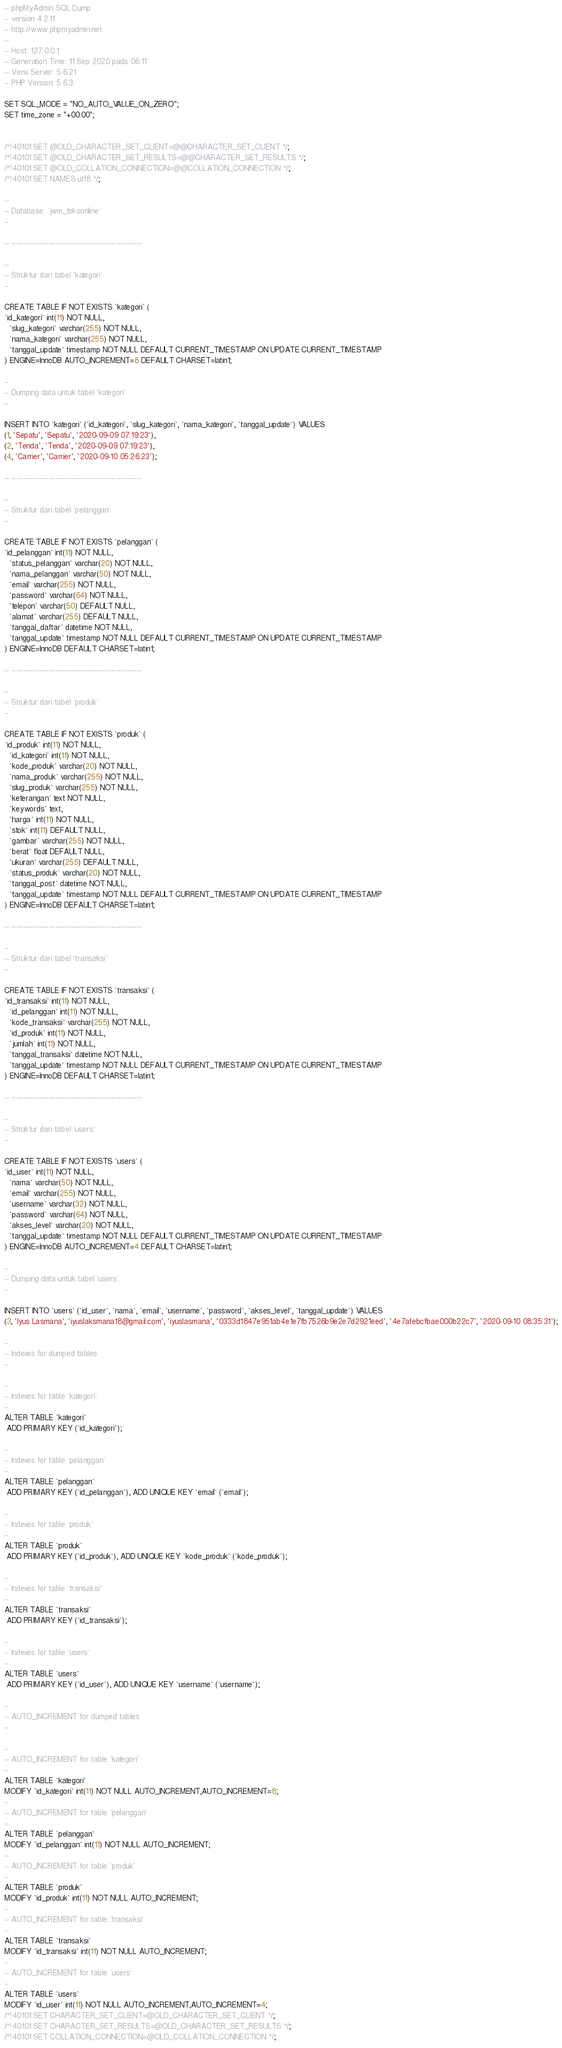<code> <loc_0><loc_0><loc_500><loc_500><_SQL_>-- phpMyAdmin SQL Dump
-- version 4.2.11
-- http://www.phpmyadmin.net
--
-- Host: 127.0.0.1
-- Generation Time: 11 Sep 2020 pada 06.11
-- Versi Server: 5.6.21
-- PHP Version: 5.6.3

SET SQL_MODE = "NO_AUTO_VALUE_ON_ZERO";
SET time_zone = "+00:00";


/*!40101 SET @OLD_CHARACTER_SET_CLIENT=@@CHARACTER_SET_CLIENT */;
/*!40101 SET @OLD_CHARACTER_SET_RESULTS=@@CHARACTER_SET_RESULTS */;
/*!40101 SET @OLD_COLLATION_CONNECTION=@@COLLATION_CONNECTION */;
/*!40101 SET NAMES utf8 */;

--
-- Database: `jwm_tokoonline`
--

-- --------------------------------------------------------

--
-- Struktur dari tabel `kategori`
--

CREATE TABLE IF NOT EXISTS `kategori` (
`id_kategori` int(11) NOT NULL,
  `slug_kategori` varchar(255) NOT NULL,
  `nama_kategori` varchar(255) NOT NULL,
  `tanggal_update` timestamp NOT NULL DEFAULT CURRENT_TIMESTAMP ON UPDATE CURRENT_TIMESTAMP
) ENGINE=InnoDB AUTO_INCREMENT=8 DEFAULT CHARSET=latin1;

--
-- Dumping data untuk tabel `kategori`
--

INSERT INTO `kategori` (`id_kategori`, `slug_kategori`, `nama_kategori`, `tanggal_update`) VALUES
(1, 'Sepatu', 'Sepatu', '2020-09-09 07:19:23'),
(2, 'Tenda', 'Tenda', '2020-09-09 07:19:23'),
(4, 'Carrier', 'Carrier', '2020-09-10 05:26:23');

-- --------------------------------------------------------

--
-- Struktur dari tabel `pelanggan`
--

CREATE TABLE IF NOT EXISTS `pelanggan` (
`id_pelanggan` int(11) NOT NULL,
  `status_pelanggan` varchar(20) NOT NULL,
  `nama_pelanggan` varchar(50) NOT NULL,
  `email` varchar(255) NOT NULL,
  `password` varchar(64) NOT NULL,
  `telepon` varchar(50) DEFAULT NULL,
  `alamat` varchar(255) DEFAULT NULL,
  `tanggal_daftar` datetime NOT NULL,
  `tanggal_update` timestamp NOT NULL DEFAULT CURRENT_TIMESTAMP ON UPDATE CURRENT_TIMESTAMP
) ENGINE=InnoDB DEFAULT CHARSET=latin1;

-- --------------------------------------------------------

--
-- Struktur dari tabel `produk`
--

CREATE TABLE IF NOT EXISTS `produk` (
`id_produk` int(11) NOT NULL,
  `id_kategori` int(11) NOT NULL,
  `kode_produk` varchar(20) NOT NULL,
  `nama_produk` varchar(255) NOT NULL,
  `slug_produk` varchar(255) NOT NULL,
  `keterangan` text NOT NULL,
  `keywords` text,
  `harga` int(11) NOT NULL,
  `stok` int(11) DEFAULT NULL,
  `gambar` varchar(255) NOT NULL,
  `berat` float DEFAULT NULL,
  `ukuran` varchar(255) DEFAULT NULL,
  `status_produk` varchar(20) NOT NULL,
  `tanggal_post` datetime NOT NULL,
  `tanggal_update` timestamp NOT NULL DEFAULT CURRENT_TIMESTAMP ON UPDATE CURRENT_TIMESTAMP
) ENGINE=InnoDB DEFAULT CHARSET=latin1;

-- --------------------------------------------------------

--
-- Struktur dari tabel `transaksi`
--

CREATE TABLE IF NOT EXISTS `transaksi` (
`id_transaksi` int(11) NOT NULL,
  `id_pelanggan` int(11) NOT NULL,
  `kode_transaksi` varchar(255) NOT NULL,
  `id_produk` int(11) NOT NULL,
  `jumlah` int(11) NOT NULL,
  `tanggal_transaksi` datetime NOT NULL,
  `tanggal_update` timestamp NOT NULL DEFAULT CURRENT_TIMESTAMP ON UPDATE CURRENT_TIMESTAMP
) ENGINE=InnoDB DEFAULT CHARSET=latin1;

-- --------------------------------------------------------

--
-- Struktur dari tabel `users`
--

CREATE TABLE IF NOT EXISTS `users` (
`id_user` int(11) NOT NULL,
  `nama` varchar(50) NOT NULL,
  `email` varchar(255) NOT NULL,
  `username` varchar(32) NOT NULL,
  `password` varchar(64) NOT NULL,
  `akses_level` varchar(20) NOT NULL,
  `tanggal_update` timestamp NOT NULL DEFAULT CURRENT_TIMESTAMP ON UPDATE CURRENT_TIMESTAMP
) ENGINE=InnoDB AUTO_INCREMENT=4 DEFAULT CHARSET=latin1;

--
-- Dumping data untuk tabel `users`
--

INSERT INTO `users` (`id_user`, `nama`, `email`, `username`, `password`, `akses_level`, `tanggal_update`) VALUES
(3, 'Iyus Lasmana', 'iyuslaksmana18@gmail.com', 'iyuslasmana', '0333d1847e951ab4e1e7fb7526b9e2e7d2921eed', '4e7afebcfbae000b22c7', '2020-09-10 08:35:31');

--
-- Indexes for dumped tables
--

--
-- Indexes for table `kategori`
--
ALTER TABLE `kategori`
 ADD PRIMARY KEY (`id_kategori`);

--
-- Indexes for table `pelanggan`
--
ALTER TABLE `pelanggan`
 ADD PRIMARY KEY (`id_pelanggan`), ADD UNIQUE KEY `email` (`email`);

--
-- Indexes for table `produk`
--
ALTER TABLE `produk`
 ADD PRIMARY KEY (`id_produk`), ADD UNIQUE KEY `kode_produk` (`kode_produk`);

--
-- Indexes for table `transaksi`
--
ALTER TABLE `transaksi`
 ADD PRIMARY KEY (`id_transaksi`);

--
-- Indexes for table `users`
--
ALTER TABLE `users`
 ADD PRIMARY KEY (`id_user`), ADD UNIQUE KEY `username` (`username`);

--
-- AUTO_INCREMENT for dumped tables
--

--
-- AUTO_INCREMENT for table `kategori`
--
ALTER TABLE `kategori`
MODIFY `id_kategori` int(11) NOT NULL AUTO_INCREMENT,AUTO_INCREMENT=8;
--
-- AUTO_INCREMENT for table `pelanggan`
--
ALTER TABLE `pelanggan`
MODIFY `id_pelanggan` int(11) NOT NULL AUTO_INCREMENT;
--
-- AUTO_INCREMENT for table `produk`
--
ALTER TABLE `produk`
MODIFY `id_produk` int(11) NOT NULL AUTO_INCREMENT;
--
-- AUTO_INCREMENT for table `transaksi`
--
ALTER TABLE `transaksi`
MODIFY `id_transaksi` int(11) NOT NULL AUTO_INCREMENT;
--
-- AUTO_INCREMENT for table `users`
--
ALTER TABLE `users`
MODIFY `id_user` int(11) NOT NULL AUTO_INCREMENT,AUTO_INCREMENT=4;
/*!40101 SET CHARACTER_SET_CLIENT=@OLD_CHARACTER_SET_CLIENT */;
/*!40101 SET CHARACTER_SET_RESULTS=@OLD_CHARACTER_SET_RESULTS */;
/*!40101 SET COLLATION_CONNECTION=@OLD_COLLATION_CONNECTION */;
</code> 